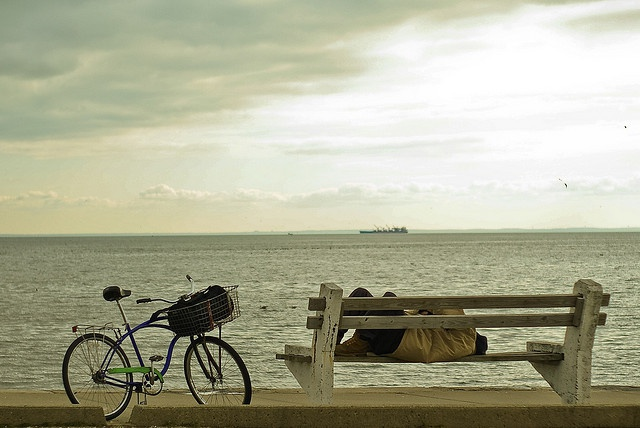Describe the objects in this image and their specific colors. I can see bench in gray, black, darkgreen, and olive tones, bicycle in gray, black, and darkgray tones, people in gray, black, olive, and tan tones, handbag in gray, black, and darkgreen tones, and boat in gray, beige, and darkgray tones in this image. 